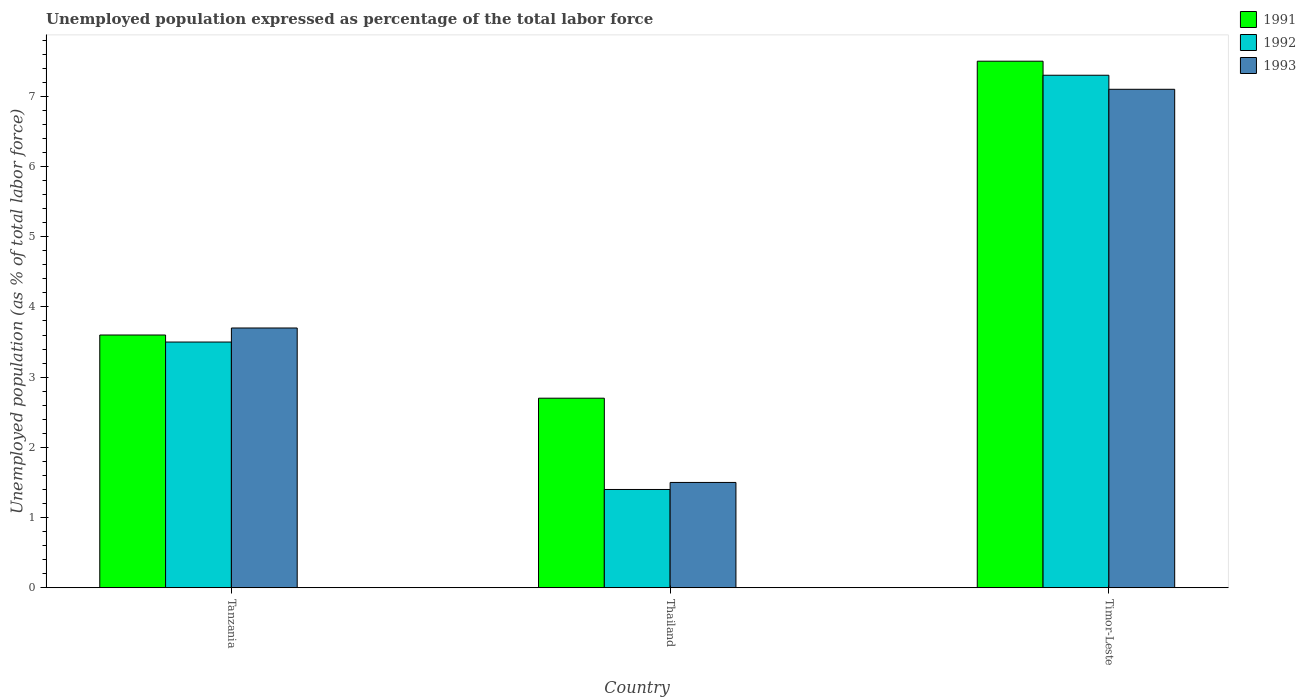How many different coloured bars are there?
Your response must be concise. 3. Are the number of bars per tick equal to the number of legend labels?
Give a very brief answer. Yes. How many bars are there on the 3rd tick from the left?
Keep it short and to the point. 3. How many bars are there on the 1st tick from the right?
Give a very brief answer. 3. What is the label of the 2nd group of bars from the left?
Keep it short and to the point. Thailand. What is the unemployment in in 1993 in Timor-Leste?
Provide a short and direct response. 7.1. Across all countries, what is the maximum unemployment in in 1993?
Ensure brevity in your answer.  7.1. Across all countries, what is the minimum unemployment in in 1993?
Your answer should be compact. 1.5. In which country was the unemployment in in 1991 maximum?
Make the answer very short. Timor-Leste. In which country was the unemployment in in 1992 minimum?
Your answer should be very brief. Thailand. What is the total unemployment in in 1992 in the graph?
Keep it short and to the point. 12.2. What is the difference between the unemployment in in 1992 in Thailand and that in Timor-Leste?
Your answer should be compact. -5.9. What is the difference between the unemployment in in 1993 in Thailand and the unemployment in in 1992 in Tanzania?
Offer a terse response. -2. What is the average unemployment in in 1993 per country?
Provide a short and direct response. 4.1. What is the difference between the unemployment in of/in 1993 and unemployment in of/in 1992 in Thailand?
Offer a terse response. 0.1. In how many countries, is the unemployment in in 1992 greater than 4.6 %?
Keep it short and to the point. 1. What is the ratio of the unemployment in in 1993 in Tanzania to that in Timor-Leste?
Your answer should be very brief. 0.52. Is the unemployment in in 1993 in Thailand less than that in Timor-Leste?
Make the answer very short. Yes. What is the difference between the highest and the second highest unemployment in in 1992?
Provide a succinct answer. -2.1. What is the difference between the highest and the lowest unemployment in in 1991?
Keep it short and to the point. 4.8. What does the 3rd bar from the left in Thailand represents?
Give a very brief answer. 1993. How many bars are there?
Ensure brevity in your answer.  9. Are all the bars in the graph horizontal?
Offer a very short reply. No. How many countries are there in the graph?
Keep it short and to the point. 3. Does the graph contain any zero values?
Offer a very short reply. No. Does the graph contain grids?
Ensure brevity in your answer.  No. How are the legend labels stacked?
Make the answer very short. Vertical. What is the title of the graph?
Give a very brief answer. Unemployed population expressed as percentage of the total labor force. What is the label or title of the Y-axis?
Your response must be concise. Unemployed population (as % of total labor force). What is the Unemployed population (as % of total labor force) in 1991 in Tanzania?
Your response must be concise. 3.6. What is the Unemployed population (as % of total labor force) of 1993 in Tanzania?
Offer a terse response. 3.7. What is the Unemployed population (as % of total labor force) in 1991 in Thailand?
Make the answer very short. 2.7. What is the Unemployed population (as % of total labor force) of 1992 in Thailand?
Your answer should be compact. 1.4. What is the Unemployed population (as % of total labor force) in 1991 in Timor-Leste?
Keep it short and to the point. 7.5. What is the Unemployed population (as % of total labor force) in 1992 in Timor-Leste?
Your response must be concise. 7.3. What is the Unemployed population (as % of total labor force) in 1993 in Timor-Leste?
Your answer should be very brief. 7.1. Across all countries, what is the maximum Unemployed population (as % of total labor force) of 1992?
Give a very brief answer. 7.3. Across all countries, what is the maximum Unemployed population (as % of total labor force) in 1993?
Ensure brevity in your answer.  7.1. Across all countries, what is the minimum Unemployed population (as % of total labor force) in 1991?
Give a very brief answer. 2.7. Across all countries, what is the minimum Unemployed population (as % of total labor force) of 1992?
Your answer should be very brief. 1.4. Across all countries, what is the minimum Unemployed population (as % of total labor force) in 1993?
Provide a succinct answer. 1.5. What is the total Unemployed population (as % of total labor force) of 1991 in the graph?
Offer a very short reply. 13.8. What is the difference between the Unemployed population (as % of total labor force) of 1991 in Tanzania and that in Thailand?
Offer a terse response. 0.9. What is the difference between the Unemployed population (as % of total labor force) of 1992 in Tanzania and that in Thailand?
Keep it short and to the point. 2.1. What is the difference between the Unemployed population (as % of total labor force) of 1993 in Tanzania and that in Thailand?
Offer a very short reply. 2.2. What is the difference between the Unemployed population (as % of total labor force) in 1991 in Tanzania and that in Timor-Leste?
Keep it short and to the point. -3.9. What is the difference between the Unemployed population (as % of total labor force) in 1992 in Tanzania and that in Timor-Leste?
Provide a short and direct response. -3.8. What is the difference between the Unemployed population (as % of total labor force) in 1993 in Tanzania and that in Timor-Leste?
Provide a succinct answer. -3.4. What is the difference between the Unemployed population (as % of total labor force) of 1991 in Thailand and that in Timor-Leste?
Your answer should be very brief. -4.8. What is the difference between the Unemployed population (as % of total labor force) of 1992 in Thailand and that in Timor-Leste?
Make the answer very short. -5.9. What is the difference between the Unemployed population (as % of total labor force) in 1991 in Tanzania and the Unemployed population (as % of total labor force) in 1993 in Thailand?
Your response must be concise. 2.1. What is the difference between the Unemployed population (as % of total labor force) in 1992 in Tanzania and the Unemployed population (as % of total labor force) in 1993 in Thailand?
Offer a terse response. 2. What is the average Unemployed population (as % of total labor force) in 1991 per country?
Offer a terse response. 4.6. What is the average Unemployed population (as % of total labor force) of 1992 per country?
Offer a terse response. 4.07. What is the average Unemployed population (as % of total labor force) in 1993 per country?
Make the answer very short. 4.1. What is the ratio of the Unemployed population (as % of total labor force) of 1991 in Tanzania to that in Thailand?
Provide a short and direct response. 1.33. What is the ratio of the Unemployed population (as % of total labor force) in 1992 in Tanzania to that in Thailand?
Your answer should be very brief. 2.5. What is the ratio of the Unemployed population (as % of total labor force) of 1993 in Tanzania to that in Thailand?
Ensure brevity in your answer.  2.47. What is the ratio of the Unemployed population (as % of total labor force) of 1991 in Tanzania to that in Timor-Leste?
Give a very brief answer. 0.48. What is the ratio of the Unemployed population (as % of total labor force) of 1992 in Tanzania to that in Timor-Leste?
Give a very brief answer. 0.48. What is the ratio of the Unemployed population (as % of total labor force) in 1993 in Tanzania to that in Timor-Leste?
Your answer should be very brief. 0.52. What is the ratio of the Unemployed population (as % of total labor force) in 1991 in Thailand to that in Timor-Leste?
Your answer should be very brief. 0.36. What is the ratio of the Unemployed population (as % of total labor force) in 1992 in Thailand to that in Timor-Leste?
Your answer should be compact. 0.19. What is the ratio of the Unemployed population (as % of total labor force) in 1993 in Thailand to that in Timor-Leste?
Give a very brief answer. 0.21. What is the difference between the highest and the second highest Unemployed population (as % of total labor force) in 1991?
Provide a succinct answer. 3.9. What is the difference between the highest and the lowest Unemployed population (as % of total labor force) of 1991?
Ensure brevity in your answer.  4.8. What is the difference between the highest and the lowest Unemployed population (as % of total labor force) of 1993?
Your answer should be compact. 5.6. 